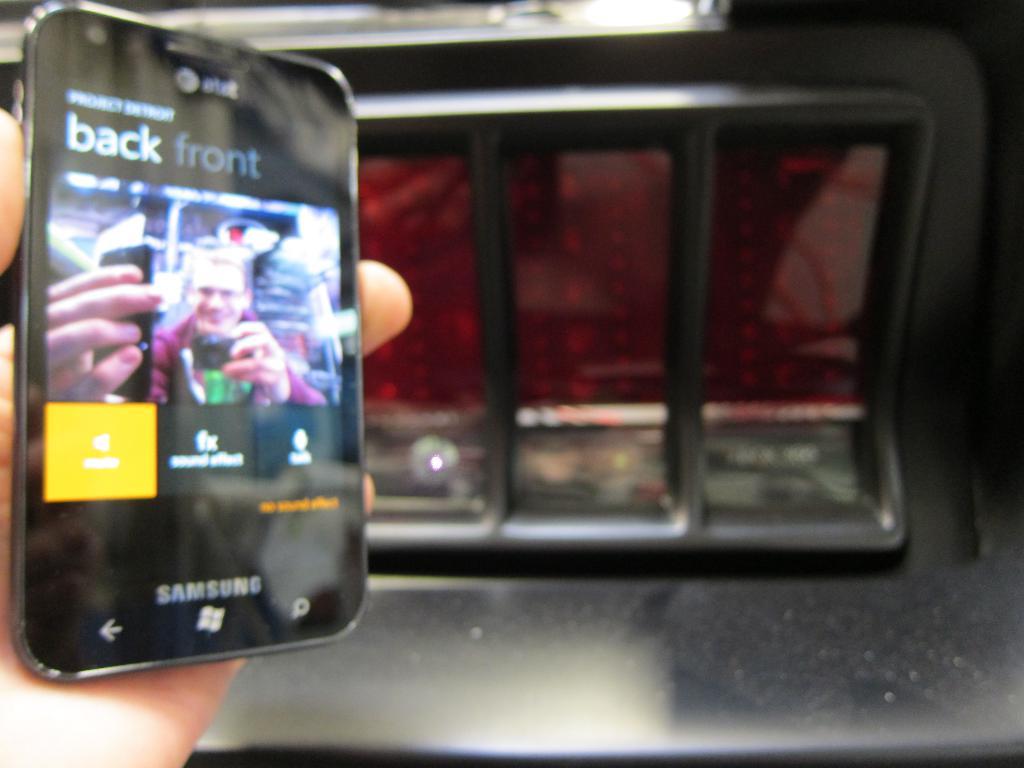What brand of phone is this?
Make the answer very short. Samsung. Can this phone be unlocked from at&t?
Provide a short and direct response. Unanswerable. 